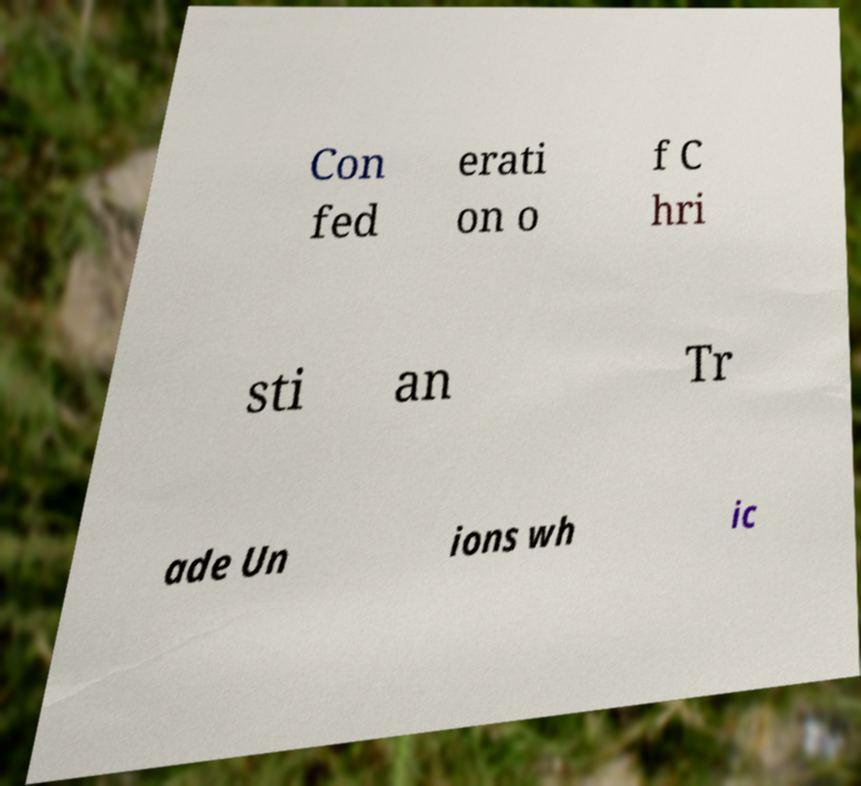For documentation purposes, I need the text within this image transcribed. Could you provide that? Con fed erati on o f C hri sti an Tr ade Un ions wh ic 